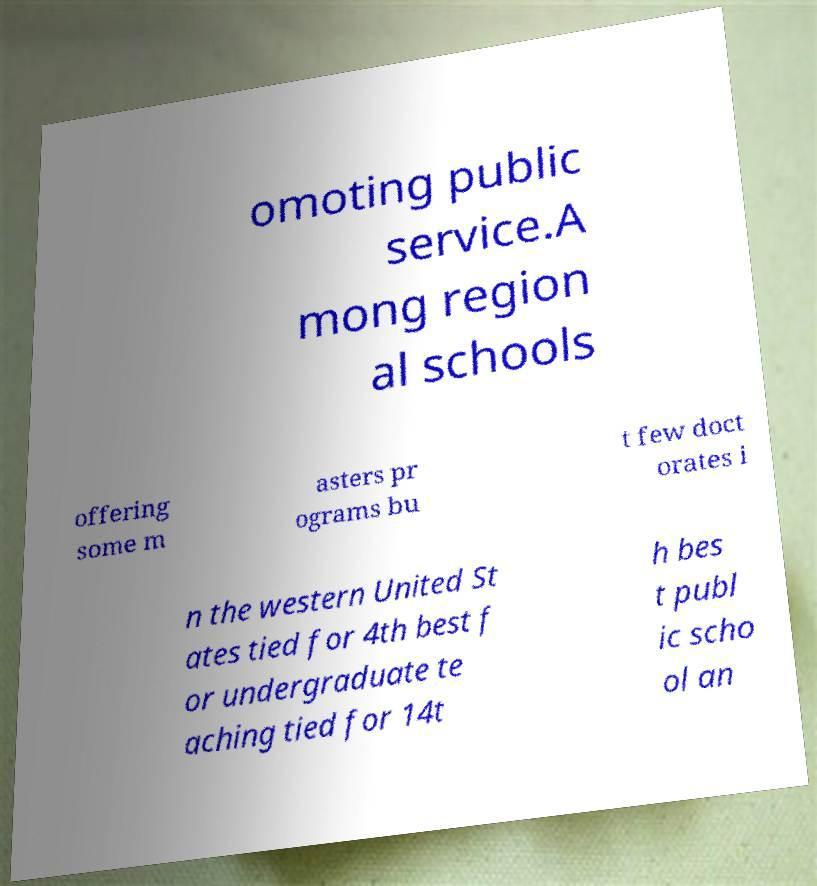Could you extract and type out the text from this image? omoting public service.A mong region al schools offering some m asters pr ograms bu t few doct orates i n the western United St ates tied for 4th best f or undergraduate te aching tied for 14t h bes t publ ic scho ol an 